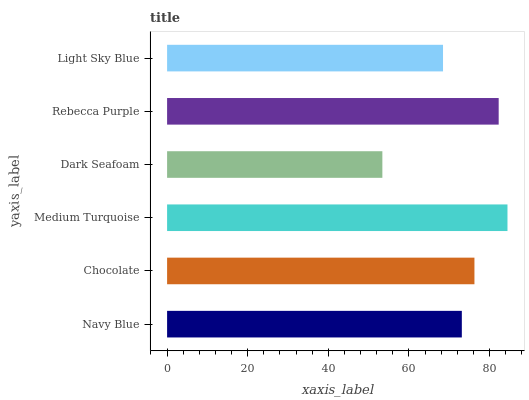Is Dark Seafoam the minimum?
Answer yes or no. Yes. Is Medium Turquoise the maximum?
Answer yes or no. Yes. Is Chocolate the minimum?
Answer yes or no. No. Is Chocolate the maximum?
Answer yes or no. No. Is Chocolate greater than Navy Blue?
Answer yes or no. Yes. Is Navy Blue less than Chocolate?
Answer yes or no. Yes. Is Navy Blue greater than Chocolate?
Answer yes or no. No. Is Chocolate less than Navy Blue?
Answer yes or no. No. Is Chocolate the high median?
Answer yes or no. Yes. Is Navy Blue the low median?
Answer yes or no. Yes. Is Light Sky Blue the high median?
Answer yes or no. No. Is Light Sky Blue the low median?
Answer yes or no. No. 